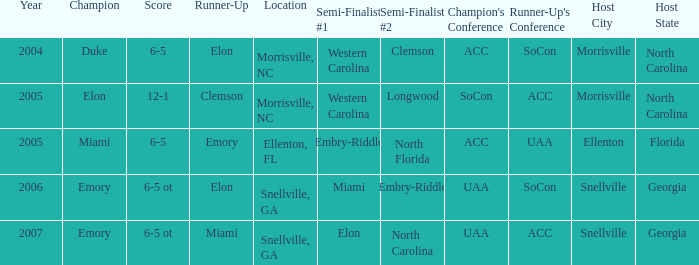How many teams were listed as runner up in 2005 and there the first semi finalist was Western Carolina? 1.0. 